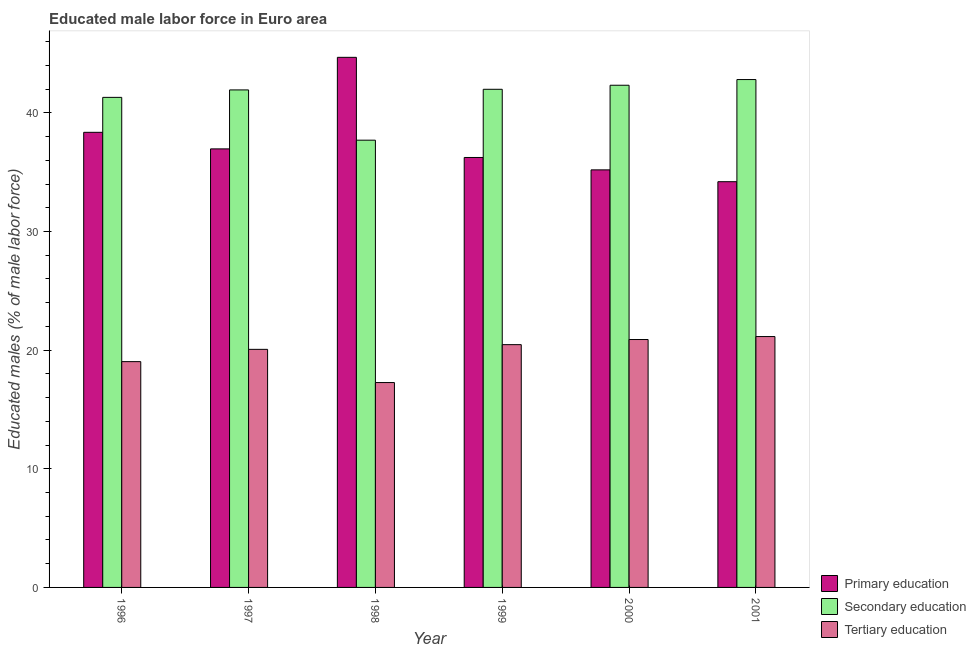Are the number of bars per tick equal to the number of legend labels?
Keep it short and to the point. Yes. How many bars are there on the 4th tick from the left?
Ensure brevity in your answer.  3. How many bars are there on the 6th tick from the right?
Keep it short and to the point. 3. What is the label of the 1st group of bars from the left?
Offer a very short reply. 1996. In how many cases, is the number of bars for a given year not equal to the number of legend labels?
Your answer should be very brief. 0. What is the percentage of male labor force who received primary education in 1997?
Your answer should be very brief. 36.96. Across all years, what is the maximum percentage of male labor force who received primary education?
Make the answer very short. 44.68. Across all years, what is the minimum percentage of male labor force who received primary education?
Keep it short and to the point. 34.2. In which year was the percentage of male labor force who received tertiary education maximum?
Your answer should be compact. 2001. What is the total percentage of male labor force who received secondary education in the graph?
Your response must be concise. 248.07. What is the difference between the percentage of male labor force who received primary education in 1997 and that in 2001?
Keep it short and to the point. 2.77. What is the difference between the percentage of male labor force who received tertiary education in 2000 and the percentage of male labor force who received primary education in 1999?
Ensure brevity in your answer.  0.43. What is the average percentage of male labor force who received tertiary education per year?
Ensure brevity in your answer.  19.81. In how many years, is the percentage of male labor force who received secondary education greater than 6 %?
Your response must be concise. 6. What is the ratio of the percentage of male labor force who received tertiary education in 1998 to that in 1999?
Your response must be concise. 0.84. Is the difference between the percentage of male labor force who received secondary education in 1996 and 1999 greater than the difference between the percentage of male labor force who received tertiary education in 1996 and 1999?
Your answer should be very brief. No. What is the difference between the highest and the second highest percentage of male labor force who received primary education?
Offer a very short reply. 6.32. What is the difference between the highest and the lowest percentage of male labor force who received secondary education?
Provide a succinct answer. 5.11. In how many years, is the percentage of male labor force who received primary education greater than the average percentage of male labor force who received primary education taken over all years?
Give a very brief answer. 2. Is the sum of the percentage of male labor force who received tertiary education in 1997 and 1998 greater than the maximum percentage of male labor force who received primary education across all years?
Offer a very short reply. Yes. What does the 2nd bar from the left in 2000 represents?
Keep it short and to the point. Secondary education. What does the 1st bar from the right in 2001 represents?
Offer a very short reply. Tertiary education. Is it the case that in every year, the sum of the percentage of male labor force who received primary education and percentage of male labor force who received secondary education is greater than the percentage of male labor force who received tertiary education?
Keep it short and to the point. Yes. How many years are there in the graph?
Ensure brevity in your answer.  6. What is the difference between two consecutive major ticks on the Y-axis?
Keep it short and to the point. 10. Are the values on the major ticks of Y-axis written in scientific E-notation?
Offer a terse response. No. How many legend labels are there?
Keep it short and to the point. 3. How are the legend labels stacked?
Your answer should be very brief. Vertical. What is the title of the graph?
Provide a succinct answer. Educated male labor force in Euro area. Does "Oil" appear as one of the legend labels in the graph?
Ensure brevity in your answer.  No. What is the label or title of the Y-axis?
Your answer should be compact. Educated males (% of male labor force). What is the Educated males (% of male labor force) of Primary education in 1996?
Offer a terse response. 38.36. What is the Educated males (% of male labor force) in Secondary education in 1996?
Provide a succinct answer. 41.31. What is the Educated males (% of male labor force) in Tertiary education in 1996?
Make the answer very short. 19.03. What is the Educated males (% of male labor force) in Primary education in 1997?
Offer a very short reply. 36.96. What is the Educated males (% of male labor force) of Secondary education in 1997?
Your answer should be compact. 41.94. What is the Educated males (% of male labor force) in Tertiary education in 1997?
Offer a very short reply. 20.07. What is the Educated males (% of male labor force) of Primary education in 1998?
Keep it short and to the point. 44.68. What is the Educated males (% of male labor force) of Secondary education in 1998?
Offer a very short reply. 37.7. What is the Educated males (% of male labor force) in Tertiary education in 1998?
Provide a short and direct response. 17.27. What is the Educated males (% of male labor force) in Primary education in 1999?
Give a very brief answer. 36.24. What is the Educated males (% of male labor force) in Secondary education in 1999?
Make the answer very short. 41.99. What is the Educated males (% of male labor force) of Tertiary education in 1999?
Provide a succinct answer. 20.46. What is the Educated males (% of male labor force) in Primary education in 2000?
Give a very brief answer. 35.2. What is the Educated males (% of male labor force) in Secondary education in 2000?
Give a very brief answer. 42.33. What is the Educated males (% of male labor force) in Tertiary education in 2000?
Give a very brief answer. 20.9. What is the Educated males (% of male labor force) of Primary education in 2001?
Offer a terse response. 34.2. What is the Educated males (% of male labor force) in Secondary education in 2001?
Provide a succinct answer. 42.81. What is the Educated males (% of male labor force) of Tertiary education in 2001?
Keep it short and to the point. 21.15. Across all years, what is the maximum Educated males (% of male labor force) in Primary education?
Offer a terse response. 44.68. Across all years, what is the maximum Educated males (% of male labor force) of Secondary education?
Give a very brief answer. 42.81. Across all years, what is the maximum Educated males (% of male labor force) in Tertiary education?
Give a very brief answer. 21.15. Across all years, what is the minimum Educated males (% of male labor force) of Primary education?
Keep it short and to the point. 34.2. Across all years, what is the minimum Educated males (% of male labor force) in Secondary education?
Make the answer very short. 37.7. Across all years, what is the minimum Educated males (% of male labor force) in Tertiary education?
Give a very brief answer. 17.27. What is the total Educated males (% of male labor force) in Primary education in the graph?
Ensure brevity in your answer.  225.64. What is the total Educated males (% of male labor force) of Secondary education in the graph?
Offer a very short reply. 248.07. What is the total Educated males (% of male labor force) of Tertiary education in the graph?
Offer a very short reply. 118.87. What is the difference between the Educated males (% of male labor force) in Primary education in 1996 and that in 1997?
Ensure brevity in your answer.  1.4. What is the difference between the Educated males (% of male labor force) in Secondary education in 1996 and that in 1997?
Keep it short and to the point. -0.63. What is the difference between the Educated males (% of male labor force) in Tertiary education in 1996 and that in 1997?
Provide a short and direct response. -1.04. What is the difference between the Educated males (% of male labor force) in Primary education in 1996 and that in 1998?
Your answer should be compact. -6.32. What is the difference between the Educated males (% of male labor force) in Secondary education in 1996 and that in 1998?
Your response must be concise. 3.61. What is the difference between the Educated males (% of male labor force) in Tertiary education in 1996 and that in 1998?
Your answer should be compact. 1.76. What is the difference between the Educated males (% of male labor force) of Primary education in 1996 and that in 1999?
Make the answer very short. 2.12. What is the difference between the Educated males (% of male labor force) of Secondary education in 1996 and that in 1999?
Make the answer very short. -0.68. What is the difference between the Educated males (% of male labor force) in Tertiary education in 1996 and that in 1999?
Your answer should be very brief. -1.43. What is the difference between the Educated males (% of male labor force) of Primary education in 1996 and that in 2000?
Your answer should be compact. 3.17. What is the difference between the Educated males (% of male labor force) in Secondary education in 1996 and that in 2000?
Provide a succinct answer. -1.02. What is the difference between the Educated males (% of male labor force) in Tertiary education in 1996 and that in 2000?
Offer a very short reply. -1.86. What is the difference between the Educated males (% of male labor force) of Primary education in 1996 and that in 2001?
Provide a succinct answer. 4.16. What is the difference between the Educated males (% of male labor force) in Secondary education in 1996 and that in 2001?
Make the answer very short. -1.5. What is the difference between the Educated males (% of male labor force) of Tertiary education in 1996 and that in 2001?
Provide a succinct answer. -2.11. What is the difference between the Educated males (% of male labor force) of Primary education in 1997 and that in 1998?
Your answer should be very brief. -7.72. What is the difference between the Educated males (% of male labor force) of Secondary education in 1997 and that in 1998?
Provide a short and direct response. 4.24. What is the difference between the Educated males (% of male labor force) of Tertiary education in 1997 and that in 1998?
Your answer should be very brief. 2.8. What is the difference between the Educated males (% of male labor force) of Primary education in 1997 and that in 1999?
Your response must be concise. 0.72. What is the difference between the Educated males (% of male labor force) in Secondary education in 1997 and that in 1999?
Your answer should be very brief. -0.05. What is the difference between the Educated males (% of male labor force) of Tertiary education in 1997 and that in 1999?
Your answer should be compact. -0.4. What is the difference between the Educated males (% of male labor force) in Primary education in 1997 and that in 2000?
Ensure brevity in your answer.  1.77. What is the difference between the Educated males (% of male labor force) of Secondary education in 1997 and that in 2000?
Your response must be concise. -0.39. What is the difference between the Educated males (% of male labor force) in Tertiary education in 1997 and that in 2000?
Offer a terse response. -0.83. What is the difference between the Educated males (% of male labor force) of Primary education in 1997 and that in 2001?
Offer a very short reply. 2.77. What is the difference between the Educated males (% of male labor force) in Secondary education in 1997 and that in 2001?
Ensure brevity in your answer.  -0.87. What is the difference between the Educated males (% of male labor force) in Tertiary education in 1997 and that in 2001?
Provide a short and direct response. -1.08. What is the difference between the Educated males (% of male labor force) of Primary education in 1998 and that in 1999?
Your response must be concise. 8.44. What is the difference between the Educated males (% of male labor force) of Secondary education in 1998 and that in 1999?
Give a very brief answer. -4.29. What is the difference between the Educated males (% of male labor force) in Tertiary education in 1998 and that in 1999?
Your answer should be very brief. -3.2. What is the difference between the Educated males (% of male labor force) in Primary education in 1998 and that in 2000?
Your answer should be very brief. 9.49. What is the difference between the Educated males (% of male labor force) of Secondary education in 1998 and that in 2000?
Your answer should be very brief. -4.63. What is the difference between the Educated males (% of male labor force) of Tertiary education in 1998 and that in 2000?
Offer a very short reply. -3.63. What is the difference between the Educated males (% of male labor force) in Primary education in 1998 and that in 2001?
Keep it short and to the point. 10.48. What is the difference between the Educated males (% of male labor force) of Secondary education in 1998 and that in 2001?
Make the answer very short. -5.11. What is the difference between the Educated males (% of male labor force) in Tertiary education in 1998 and that in 2001?
Give a very brief answer. -3.88. What is the difference between the Educated males (% of male labor force) in Primary education in 1999 and that in 2000?
Provide a short and direct response. 1.04. What is the difference between the Educated males (% of male labor force) of Secondary education in 1999 and that in 2000?
Your answer should be compact. -0.34. What is the difference between the Educated males (% of male labor force) of Tertiary education in 1999 and that in 2000?
Keep it short and to the point. -0.43. What is the difference between the Educated males (% of male labor force) in Primary education in 1999 and that in 2001?
Offer a very short reply. 2.04. What is the difference between the Educated males (% of male labor force) of Secondary education in 1999 and that in 2001?
Your answer should be very brief. -0.82. What is the difference between the Educated males (% of male labor force) in Tertiary education in 1999 and that in 2001?
Give a very brief answer. -0.68. What is the difference between the Educated males (% of male labor force) of Primary education in 2000 and that in 2001?
Your response must be concise. 1. What is the difference between the Educated males (% of male labor force) in Secondary education in 2000 and that in 2001?
Your answer should be very brief. -0.48. What is the difference between the Educated males (% of male labor force) in Tertiary education in 2000 and that in 2001?
Provide a succinct answer. -0.25. What is the difference between the Educated males (% of male labor force) of Primary education in 1996 and the Educated males (% of male labor force) of Secondary education in 1997?
Provide a succinct answer. -3.57. What is the difference between the Educated males (% of male labor force) of Primary education in 1996 and the Educated males (% of male labor force) of Tertiary education in 1997?
Offer a very short reply. 18.29. What is the difference between the Educated males (% of male labor force) of Secondary education in 1996 and the Educated males (% of male labor force) of Tertiary education in 1997?
Your answer should be compact. 21.24. What is the difference between the Educated males (% of male labor force) in Primary education in 1996 and the Educated males (% of male labor force) in Secondary education in 1998?
Offer a terse response. 0.66. What is the difference between the Educated males (% of male labor force) in Primary education in 1996 and the Educated males (% of male labor force) in Tertiary education in 1998?
Provide a succinct answer. 21.09. What is the difference between the Educated males (% of male labor force) of Secondary education in 1996 and the Educated males (% of male labor force) of Tertiary education in 1998?
Provide a short and direct response. 24.04. What is the difference between the Educated males (% of male labor force) in Primary education in 1996 and the Educated males (% of male labor force) in Secondary education in 1999?
Ensure brevity in your answer.  -3.63. What is the difference between the Educated males (% of male labor force) in Primary education in 1996 and the Educated males (% of male labor force) in Tertiary education in 1999?
Ensure brevity in your answer.  17.9. What is the difference between the Educated males (% of male labor force) in Secondary education in 1996 and the Educated males (% of male labor force) in Tertiary education in 1999?
Your answer should be compact. 20.84. What is the difference between the Educated males (% of male labor force) of Primary education in 1996 and the Educated males (% of male labor force) of Secondary education in 2000?
Ensure brevity in your answer.  -3.97. What is the difference between the Educated males (% of male labor force) of Primary education in 1996 and the Educated males (% of male labor force) of Tertiary education in 2000?
Give a very brief answer. 17.47. What is the difference between the Educated males (% of male labor force) in Secondary education in 1996 and the Educated males (% of male labor force) in Tertiary education in 2000?
Your answer should be very brief. 20.41. What is the difference between the Educated males (% of male labor force) of Primary education in 1996 and the Educated males (% of male labor force) of Secondary education in 2001?
Provide a succinct answer. -4.45. What is the difference between the Educated males (% of male labor force) in Primary education in 1996 and the Educated males (% of male labor force) in Tertiary education in 2001?
Provide a succinct answer. 17.22. What is the difference between the Educated males (% of male labor force) in Secondary education in 1996 and the Educated males (% of male labor force) in Tertiary education in 2001?
Offer a terse response. 20.16. What is the difference between the Educated males (% of male labor force) of Primary education in 1997 and the Educated males (% of male labor force) of Secondary education in 1998?
Ensure brevity in your answer.  -0.73. What is the difference between the Educated males (% of male labor force) in Primary education in 1997 and the Educated males (% of male labor force) in Tertiary education in 1998?
Provide a short and direct response. 19.7. What is the difference between the Educated males (% of male labor force) of Secondary education in 1997 and the Educated males (% of male labor force) of Tertiary education in 1998?
Provide a succinct answer. 24.67. What is the difference between the Educated males (% of male labor force) of Primary education in 1997 and the Educated males (% of male labor force) of Secondary education in 1999?
Give a very brief answer. -5.02. What is the difference between the Educated males (% of male labor force) of Primary education in 1997 and the Educated males (% of male labor force) of Tertiary education in 1999?
Offer a terse response. 16.5. What is the difference between the Educated males (% of male labor force) of Secondary education in 1997 and the Educated males (% of male labor force) of Tertiary education in 1999?
Your answer should be very brief. 21.47. What is the difference between the Educated males (% of male labor force) of Primary education in 1997 and the Educated males (% of male labor force) of Secondary education in 2000?
Give a very brief answer. -5.36. What is the difference between the Educated males (% of male labor force) in Primary education in 1997 and the Educated males (% of male labor force) in Tertiary education in 2000?
Offer a very short reply. 16.07. What is the difference between the Educated males (% of male labor force) of Secondary education in 1997 and the Educated males (% of male labor force) of Tertiary education in 2000?
Provide a short and direct response. 21.04. What is the difference between the Educated males (% of male labor force) in Primary education in 1997 and the Educated males (% of male labor force) in Secondary education in 2001?
Offer a very short reply. -5.84. What is the difference between the Educated males (% of male labor force) in Primary education in 1997 and the Educated males (% of male labor force) in Tertiary education in 2001?
Provide a short and direct response. 15.82. What is the difference between the Educated males (% of male labor force) of Secondary education in 1997 and the Educated males (% of male labor force) of Tertiary education in 2001?
Keep it short and to the point. 20.79. What is the difference between the Educated males (% of male labor force) of Primary education in 1998 and the Educated males (% of male labor force) of Secondary education in 1999?
Provide a short and direct response. 2.69. What is the difference between the Educated males (% of male labor force) in Primary education in 1998 and the Educated males (% of male labor force) in Tertiary education in 1999?
Make the answer very short. 24.22. What is the difference between the Educated males (% of male labor force) of Secondary education in 1998 and the Educated males (% of male labor force) of Tertiary education in 1999?
Keep it short and to the point. 17.23. What is the difference between the Educated males (% of male labor force) in Primary education in 1998 and the Educated males (% of male labor force) in Secondary education in 2000?
Offer a terse response. 2.35. What is the difference between the Educated males (% of male labor force) of Primary education in 1998 and the Educated males (% of male labor force) of Tertiary education in 2000?
Your answer should be very brief. 23.79. What is the difference between the Educated males (% of male labor force) in Secondary education in 1998 and the Educated males (% of male labor force) in Tertiary education in 2000?
Give a very brief answer. 16.8. What is the difference between the Educated males (% of male labor force) of Primary education in 1998 and the Educated males (% of male labor force) of Secondary education in 2001?
Your response must be concise. 1.87. What is the difference between the Educated males (% of male labor force) of Primary education in 1998 and the Educated males (% of male labor force) of Tertiary education in 2001?
Make the answer very short. 23.54. What is the difference between the Educated males (% of male labor force) of Secondary education in 1998 and the Educated males (% of male labor force) of Tertiary education in 2001?
Your answer should be very brief. 16.55. What is the difference between the Educated males (% of male labor force) of Primary education in 1999 and the Educated males (% of male labor force) of Secondary education in 2000?
Make the answer very short. -6.09. What is the difference between the Educated males (% of male labor force) of Primary education in 1999 and the Educated males (% of male labor force) of Tertiary education in 2000?
Make the answer very short. 15.34. What is the difference between the Educated males (% of male labor force) of Secondary education in 1999 and the Educated males (% of male labor force) of Tertiary education in 2000?
Keep it short and to the point. 21.09. What is the difference between the Educated males (% of male labor force) of Primary education in 1999 and the Educated males (% of male labor force) of Secondary education in 2001?
Provide a succinct answer. -6.57. What is the difference between the Educated males (% of male labor force) of Primary education in 1999 and the Educated males (% of male labor force) of Tertiary education in 2001?
Offer a terse response. 15.09. What is the difference between the Educated males (% of male labor force) in Secondary education in 1999 and the Educated males (% of male labor force) in Tertiary education in 2001?
Provide a succinct answer. 20.84. What is the difference between the Educated males (% of male labor force) in Primary education in 2000 and the Educated males (% of male labor force) in Secondary education in 2001?
Offer a very short reply. -7.61. What is the difference between the Educated males (% of male labor force) of Primary education in 2000 and the Educated males (% of male labor force) of Tertiary education in 2001?
Provide a short and direct response. 14.05. What is the difference between the Educated males (% of male labor force) of Secondary education in 2000 and the Educated males (% of male labor force) of Tertiary education in 2001?
Offer a terse response. 21.18. What is the average Educated males (% of male labor force) of Primary education per year?
Provide a succinct answer. 37.61. What is the average Educated males (% of male labor force) in Secondary education per year?
Your answer should be compact. 41.34. What is the average Educated males (% of male labor force) of Tertiary education per year?
Your response must be concise. 19.81. In the year 1996, what is the difference between the Educated males (% of male labor force) of Primary education and Educated males (% of male labor force) of Secondary education?
Your answer should be compact. -2.95. In the year 1996, what is the difference between the Educated males (% of male labor force) in Primary education and Educated males (% of male labor force) in Tertiary education?
Provide a short and direct response. 19.33. In the year 1996, what is the difference between the Educated males (% of male labor force) in Secondary education and Educated males (% of male labor force) in Tertiary education?
Provide a short and direct response. 22.28. In the year 1997, what is the difference between the Educated males (% of male labor force) in Primary education and Educated males (% of male labor force) in Secondary education?
Your response must be concise. -4.97. In the year 1997, what is the difference between the Educated males (% of male labor force) of Primary education and Educated males (% of male labor force) of Tertiary education?
Give a very brief answer. 16.9. In the year 1997, what is the difference between the Educated males (% of male labor force) in Secondary education and Educated males (% of male labor force) in Tertiary education?
Your response must be concise. 21.87. In the year 1998, what is the difference between the Educated males (% of male labor force) of Primary education and Educated males (% of male labor force) of Secondary education?
Offer a very short reply. 6.98. In the year 1998, what is the difference between the Educated males (% of male labor force) of Primary education and Educated males (% of male labor force) of Tertiary education?
Give a very brief answer. 27.41. In the year 1998, what is the difference between the Educated males (% of male labor force) of Secondary education and Educated males (% of male labor force) of Tertiary education?
Offer a very short reply. 20.43. In the year 1999, what is the difference between the Educated males (% of male labor force) of Primary education and Educated males (% of male labor force) of Secondary education?
Keep it short and to the point. -5.75. In the year 1999, what is the difference between the Educated males (% of male labor force) of Primary education and Educated males (% of male labor force) of Tertiary education?
Offer a terse response. 15.78. In the year 1999, what is the difference between the Educated males (% of male labor force) of Secondary education and Educated males (% of male labor force) of Tertiary education?
Ensure brevity in your answer.  21.52. In the year 2000, what is the difference between the Educated males (% of male labor force) in Primary education and Educated males (% of male labor force) in Secondary education?
Offer a very short reply. -7.13. In the year 2000, what is the difference between the Educated males (% of male labor force) in Primary education and Educated males (% of male labor force) in Tertiary education?
Ensure brevity in your answer.  14.3. In the year 2000, what is the difference between the Educated males (% of male labor force) of Secondary education and Educated males (% of male labor force) of Tertiary education?
Your answer should be very brief. 21.43. In the year 2001, what is the difference between the Educated males (% of male labor force) in Primary education and Educated males (% of male labor force) in Secondary education?
Provide a succinct answer. -8.61. In the year 2001, what is the difference between the Educated males (% of male labor force) in Primary education and Educated males (% of male labor force) in Tertiary education?
Your response must be concise. 13.05. In the year 2001, what is the difference between the Educated males (% of male labor force) of Secondary education and Educated males (% of male labor force) of Tertiary education?
Your response must be concise. 21.66. What is the ratio of the Educated males (% of male labor force) of Primary education in 1996 to that in 1997?
Your answer should be compact. 1.04. What is the ratio of the Educated males (% of male labor force) in Secondary education in 1996 to that in 1997?
Your answer should be compact. 0.98. What is the ratio of the Educated males (% of male labor force) in Tertiary education in 1996 to that in 1997?
Ensure brevity in your answer.  0.95. What is the ratio of the Educated males (% of male labor force) of Primary education in 1996 to that in 1998?
Your answer should be very brief. 0.86. What is the ratio of the Educated males (% of male labor force) in Secondary education in 1996 to that in 1998?
Your answer should be very brief. 1.1. What is the ratio of the Educated males (% of male labor force) in Tertiary education in 1996 to that in 1998?
Give a very brief answer. 1.1. What is the ratio of the Educated males (% of male labor force) of Primary education in 1996 to that in 1999?
Provide a short and direct response. 1.06. What is the ratio of the Educated males (% of male labor force) of Secondary education in 1996 to that in 1999?
Your answer should be very brief. 0.98. What is the ratio of the Educated males (% of male labor force) of Tertiary education in 1996 to that in 1999?
Ensure brevity in your answer.  0.93. What is the ratio of the Educated males (% of male labor force) of Primary education in 1996 to that in 2000?
Your answer should be compact. 1.09. What is the ratio of the Educated males (% of male labor force) of Secondary education in 1996 to that in 2000?
Give a very brief answer. 0.98. What is the ratio of the Educated males (% of male labor force) in Tertiary education in 1996 to that in 2000?
Give a very brief answer. 0.91. What is the ratio of the Educated males (% of male labor force) in Primary education in 1996 to that in 2001?
Your response must be concise. 1.12. What is the ratio of the Educated males (% of male labor force) of Secondary education in 1996 to that in 2001?
Offer a very short reply. 0.96. What is the ratio of the Educated males (% of male labor force) of Tertiary education in 1996 to that in 2001?
Provide a short and direct response. 0.9. What is the ratio of the Educated males (% of male labor force) in Primary education in 1997 to that in 1998?
Offer a very short reply. 0.83. What is the ratio of the Educated males (% of male labor force) in Secondary education in 1997 to that in 1998?
Offer a terse response. 1.11. What is the ratio of the Educated males (% of male labor force) of Tertiary education in 1997 to that in 1998?
Your answer should be compact. 1.16. What is the ratio of the Educated males (% of male labor force) in Tertiary education in 1997 to that in 1999?
Your answer should be compact. 0.98. What is the ratio of the Educated males (% of male labor force) of Primary education in 1997 to that in 2000?
Keep it short and to the point. 1.05. What is the ratio of the Educated males (% of male labor force) of Tertiary education in 1997 to that in 2000?
Your answer should be compact. 0.96. What is the ratio of the Educated males (% of male labor force) in Primary education in 1997 to that in 2001?
Provide a short and direct response. 1.08. What is the ratio of the Educated males (% of male labor force) of Secondary education in 1997 to that in 2001?
Ensure brevity in your answer.  0.98. What is the ratio of the Educated males (% of male labor force) of Tertiary education in 1997 to that in 2001?
Provide a short and direct response. 0.95. What is the ratio of the Educated males (% of male labor force) of Primary education in 1998 to that in 1999?
Give a very brief answer. 1.23. What is the ratio of the Educated males (% of male labor force) in Secondary education in 1998 to that in 1999?
Keep it short and to the point. 0.9. What is the ratio of the Educated males (% of male labor force) in Tertiary education in 1998 to that in 1999?
Your response must be concise. 0.84. What is the ratio of the Educated males (% of male labor force) of Primary education in 1998 to that in 2000?
Keep it short and to the point. 1.27. What is the ratio of the Educated males (% of male labor force) in Secondary education in 1998 to that in 2000?
Give a very brief answer. 0.89. What is the ratio of the Educated males (% of male labor force) of Tertiary education in 1998 to that in 2000?
Offer a terse response. 0.83. What is the ratio of the Educated males (% of male labor force) of Primary education in 1998 to that in 2001?
Ensure brevity in your answer.  1.31. What is the ratio of the Educated males (% of male labor force) of Secondary education in 1998 to that in 2001?
Offer a terse response. 0.88. What is the ratio of the Educated males (% of male labor force) of Tertiary education in 1998 to that in 2001?
Offer a very short reply. 0.82. What is the ratio of the Educated males (% of male labor force) in Primary education in 1999 to that in 2000?
Give a very brief answer. 1.03. What is the ratio of the Educated males (% of male labor force) of Tertiary education in 1999 to that in 2000?
Your response must be concise. 0.98. What is the ratio of the Educated males (% of male labor force) in Primary education in 1999 to that in 2001?
Give a very brief answer. 1.06. What is the ratio of the Educated males (% of male labor force) in Secondary education in 1999 to that in 2001?
Offer a terse response. 0.98. What is the ratio of the Educated males (% of male labor force) of Tertiary education in 1999 to that in 2001?
Make the answer very short. 0.97. What is the ratio of the Educated males (% of male labor force) in Primary education in 2000 to that in 2001?
Make the answer very short. 1.03. What is the ratio of the Educated males (% of male labor force) in Secondary education in 2000 to that in 2001?
Offer a very short reply. 0.99. What is the ratio of the Educated males (% of male labor force) of Tertiary education in 2000 to that in 2001?
Provide a short and direct response. 0.99. What is the difference between the highest and the second highest Educated males (% of male labor force) of Primary education?
Ensure brevity in your answer.  6.32. What is the difference between the highest and the second highest Educated males (% of male labor force) of Secondary education?
Your response must be concise. 0.48. What is the difference between the highest and the second highest Educated males (% of male labor force) of Tertiary education?
Make the answer very short. 0.25. What is the difference between the highest and the lowest Educated males (% of male labor force) in Primary education?
Your response must be concise. 10.48. What is the difference between the highest and the lowest Educated males (% of male labor force) of Secondary education?
Your response must be concise. 5.11. What is the difference between the highest and the lowest Educated males (% of male labor force) in Tertiary education?
Make the answer very short. 3.88. 